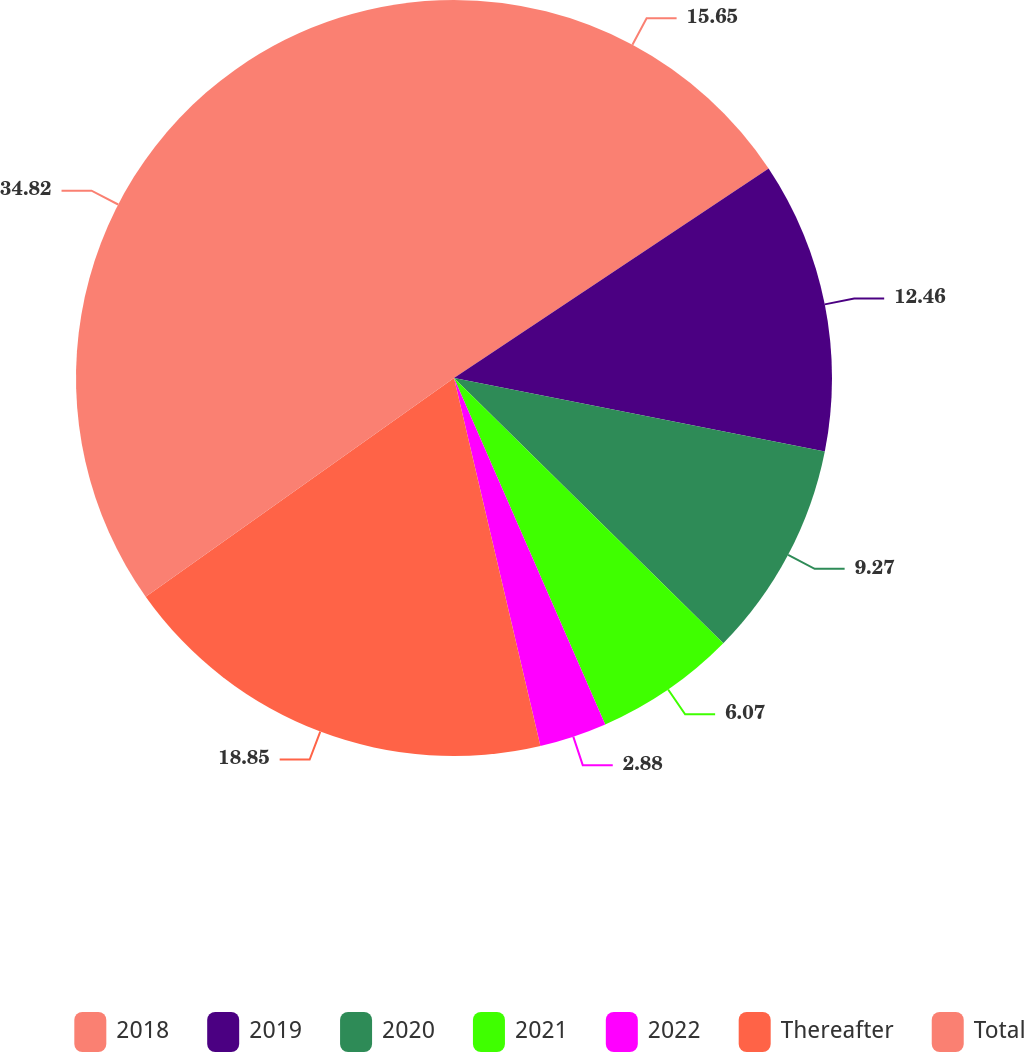Convert chart. <chart><loc_0><loc_0><loc_500><loc_500><pie_chart><fcel>2018<fcel>2019<fcel>2020<fcel>2021<fcel>2022<fcel>Thereafter<fcel>Total<nl><fcel>15.65%<fcel>12.46%<fcel>9.27%<fcel>6.07%<fcel>2.88%<fcel>18.85%<fcel>34.82%<nl></chart> 